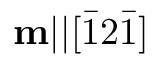Convert formula to latex. <formula><loc_0><loc_0><loc_500><loc_500>m | | [ \bar { 1 } 2 \bar { 1 } ]</formula> 